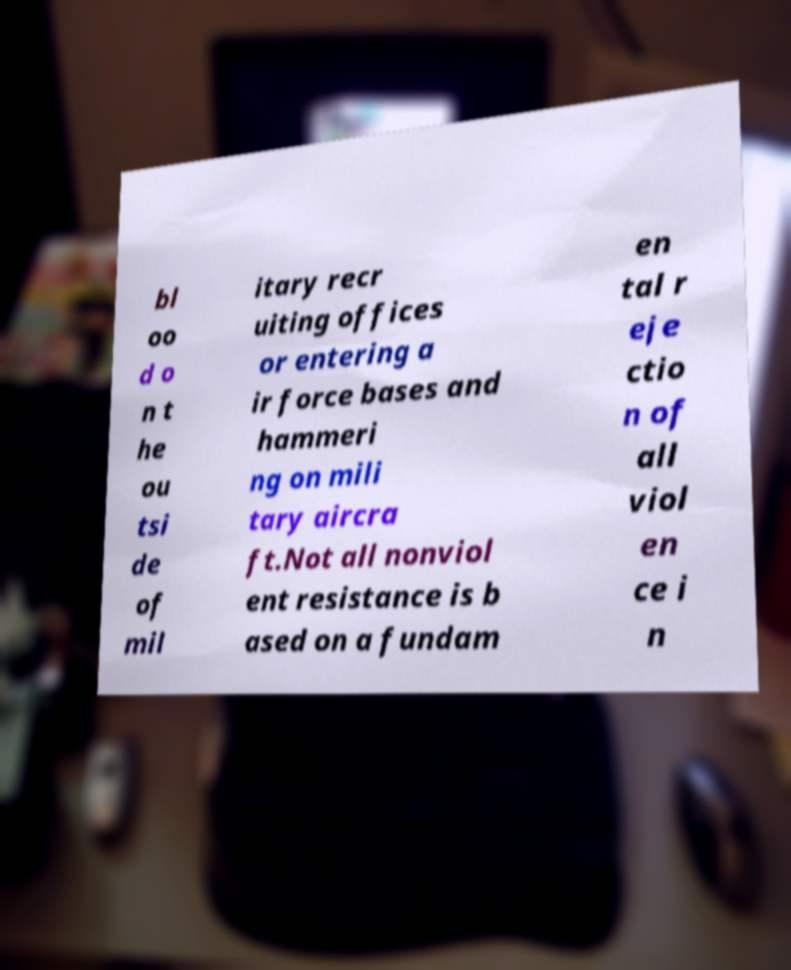Could you extract and type out the text from this image? bl oo d o n t he ou tsi de of mil itary recr uiting offices or entering a ir force bases and hammeri ng on mili tary aircra ft.Not all nonviol ent resistance is b ased on a fundam en tal r eje ctio n of all viol en ce i n 